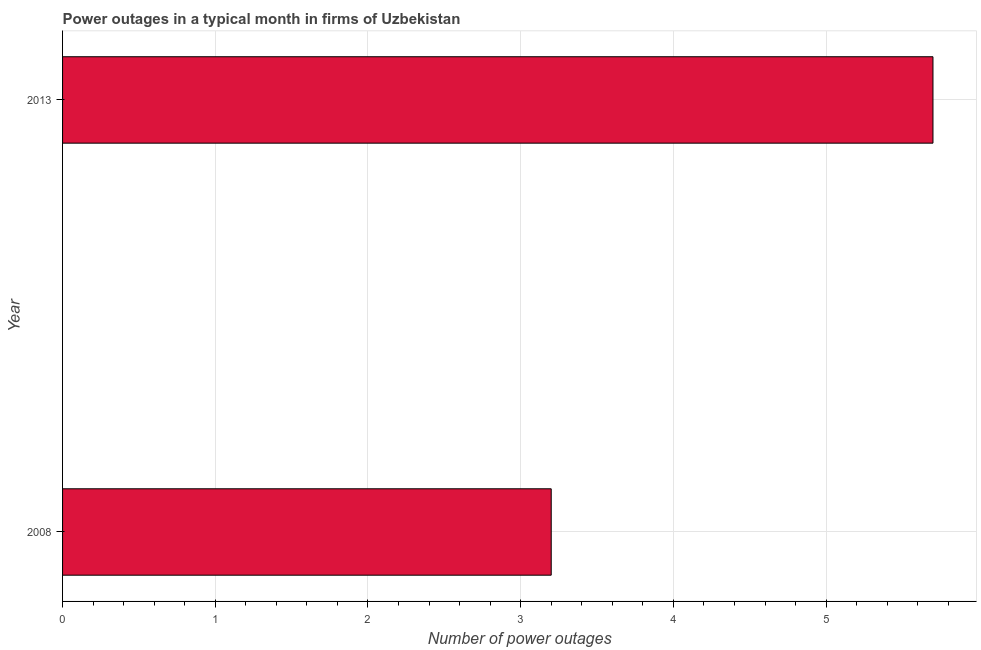Does the graph contain grids?
Make the answer very short. Yes. What is the title of the graph?
Provide a short and direct response. Power outages in a typical month in firms of Uzbekistan. What is the label or title of the X-axis?
Offer a terse response. Number of power outages. Across all years, what is the minimum number of power outages?
Make the answer very short. 3.2. What is the sum of the number of power outages?
Provide a short and direct response. 8.9. What is the average number of power outages per year?
Your response must be concise. 4.45. What is the median number of power outages?
Your response must be concise. 4.45. Do a majority of the years between 2008 and 2013 (inclusive) have number of power outages greater than 2.4 ?
Offer a very short reply. Yes. What is the ratio of the number of power outages in 2008 to that in 2013?
Provide a short and direct response. 0.56. In how many years, is the number of power outages greater than the average number of power outages taken over all years?
Offer a terse response. 1. What is the difference between two consecutive major ticks on the X-axis?
Offer a terse response. 1. What is the Number of power outages of 2013?
Give a very brief answer. 5.7. What is the difference between the Number of power outages in 2008 and 2013?
Offer a terse response. -2.5. What is the ratio of the Number of power outages in 2008 to that in 2013?
Provide a succinct answer. 0.56. 